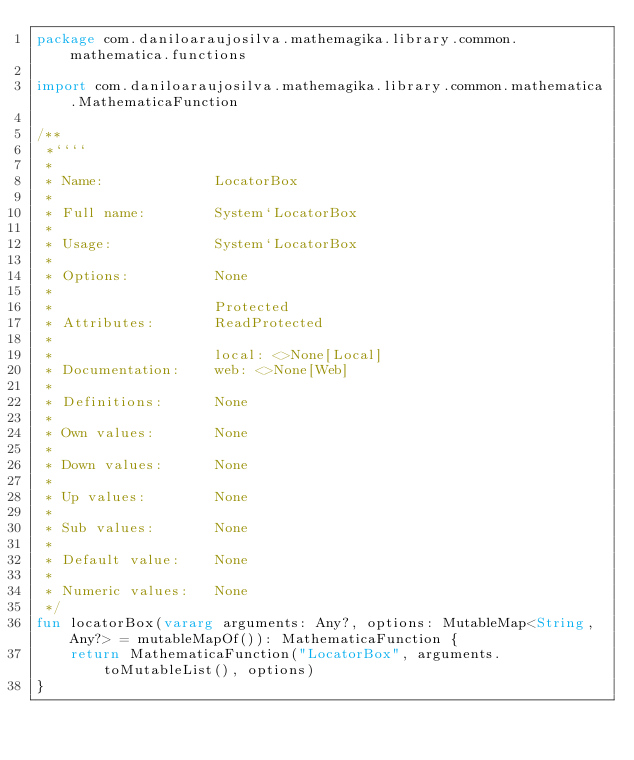Convert code to text. <code><loc_0><loc_0><loc_500><loc_500><_Kotlin_>package com.daniloaraujosilva.mathemagika.library.common.mathematica.functions

import com.daniloaraujosilva.mathemagika.library.common.mathematica.MathematicaFunction

/**
 *````
 *
 * Name:             LocatorBox
 *
 * Full name:        System`LocatorBox
 *
 * Usage:            System`LocatorBox
 *
 * Options:          None
 *
 *                   Protected
 * Attributes:       ReadProtected
 *
 *                   local: <>None[Local]
 * Documentation:    web: <>None[Web]
 *
 * Definitions:      None
 *
 * Own values:       None
 *
 * Down values:      None
 *
 * Up values:        None
 *
 * Sub values:       None
 *
 * Default value:    None
 *
 * Numeric values:   None
 */
fun locatorBox(vararg arguments: Any?, options: MutableMap<String, Any?> = mutableMapOf()): MathematicaFunction {
	return MathematicaFunction("LocatorBox", arguments.toMutableList(), options)
}
</code> 